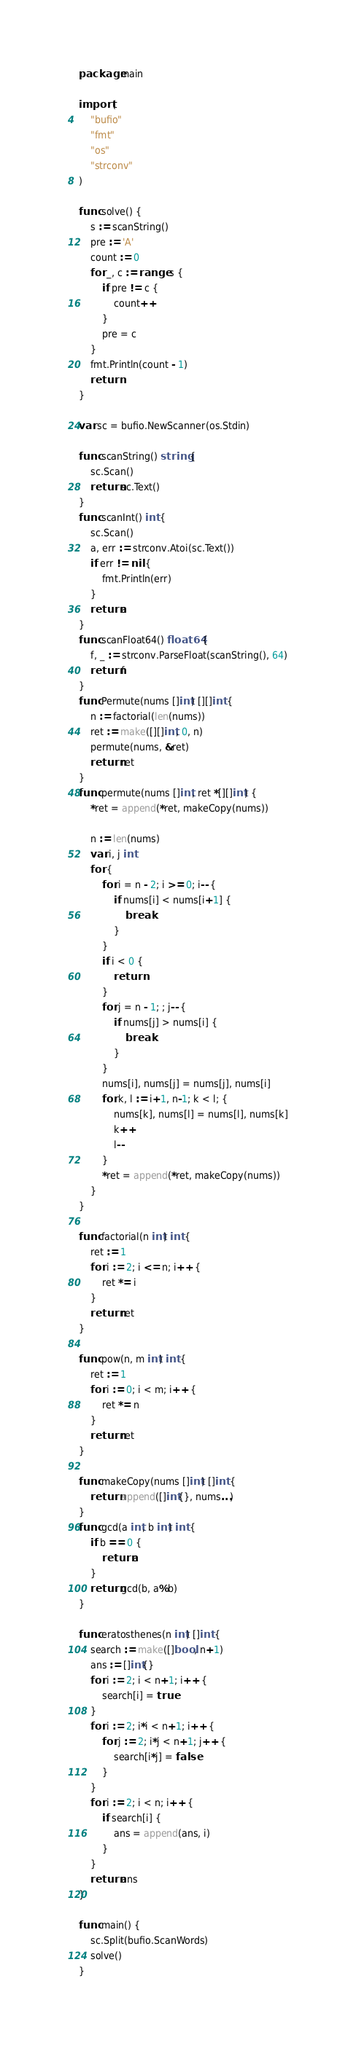Convert code to text. <code><loc_0><loc_0><loc_500><loc_500><_Go_>package main

import (
	"bufio"
	"fmt"
	"os"
	"strconv"
)

func solve() {
	s := scanString()
	pre := 'A'
	count := 0
	for _, c := range s {
		if pre != c {
			count++
		}
		pre = c
	}
	fmt.Println(count - 1)
	return
}

var sc = bufio.NewScanner(os.Stdin)

func scanString() string {
	sc.Scan()
	return sc.Text()
}
func scanInt() int {
	sc.Scan()
	a, err := strconv.Atoi(sc.Text())
	if err != nil {
		fmt.Println(err)
	}
	return a
}
func scanFloat64() float64 {
	f, _ := strconv.ParseFloat(scanString(), 64)
	return f
}
func Permute(nums []int) [][]int {
	n := factorial(len(nums))
	ret := make([][]int, 0, n)
	permute(nums, &ret)
	return ret
}
func permute(nums []int, ret *[][]int) {
	*ret = append(*ret, makeCopy(nums))

	n := len(nums)
	var i, j int
	for {
		for i = n - 2; i >= 0; i-- {
			if nums[i] < nums[i+1] {
				break
			}
		}
		if i < 0 {
			return
		}
		for j = n - 1; ; j-- {
			if nums[j] > nums[i] {
				break
			}
		}
		nums[i], nums[j] = nums[j], nums[i]
		for k, l := i+1, n-1; k < l; {
			nums[k], nums[l] = nums[l], nums[k]
			k++
			l--
		}
		*ret = append(*ret, makeCopy(nums))
	}
}

func factorial(n int) int {
	ret := 1
	for i := 2; i <= n; i++ {
		ret *= i
	}
	return ret
}

func pow(n, m int) int {
	ret := 1
	for i := 0; i < m; i++ {
		ret *= n
	}
	return ret
}

func makeCopy(nums []int) []int {
	return append([]int{}, nums...)
}
func gcd(a int, b int) int {
	if b == 0 {
		return a
	}
	return gcd(b, a%b)
}

func eratosthenes(n int) []int {
	search := make([]bool, n+1)
	ans := []int{}
	for i := 2; i < n+1; i++ {
		search[i] = true
	}
	for i := 2; i*i < n+1; i++ {
		for j := 2; i*j < n+1; j++ {
			search[i*j] = false
		}
	}
	for i := 2; i < n; i++ {
		if search[i] {
			ans = append(ans, i)
		}
	}
	return ans
}

func main() {
	sc.Split(bufio.ScanWords)
	solve()
}
</code> 